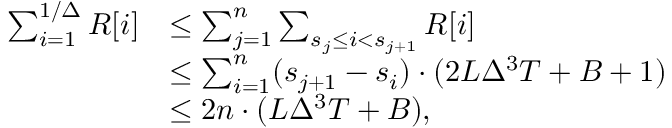<formula> <loc_0><loc_0><loc_500><loc_500>\begin{array} { r l } { \sum _ { i = 1 } ^ { 1 / \Delta } R [ i ] } & { \leq \sum _ { j = 1 } ^ { n } \sum _ { s _ { j } \leq i < s _ { j + 1 } } R [ i ] } \\ & { \leq \sum _ { i = 1 } ^ { n } ( s _ { j + 1 } - s _ { i } ) \cdot ( 2 L \Delta ^ { 3 } T + B + 1 ) } \\ & { \leq 2 n \cdot ( L \Delta ^ { 3 } T + B ) , } \end{array}</formula> 